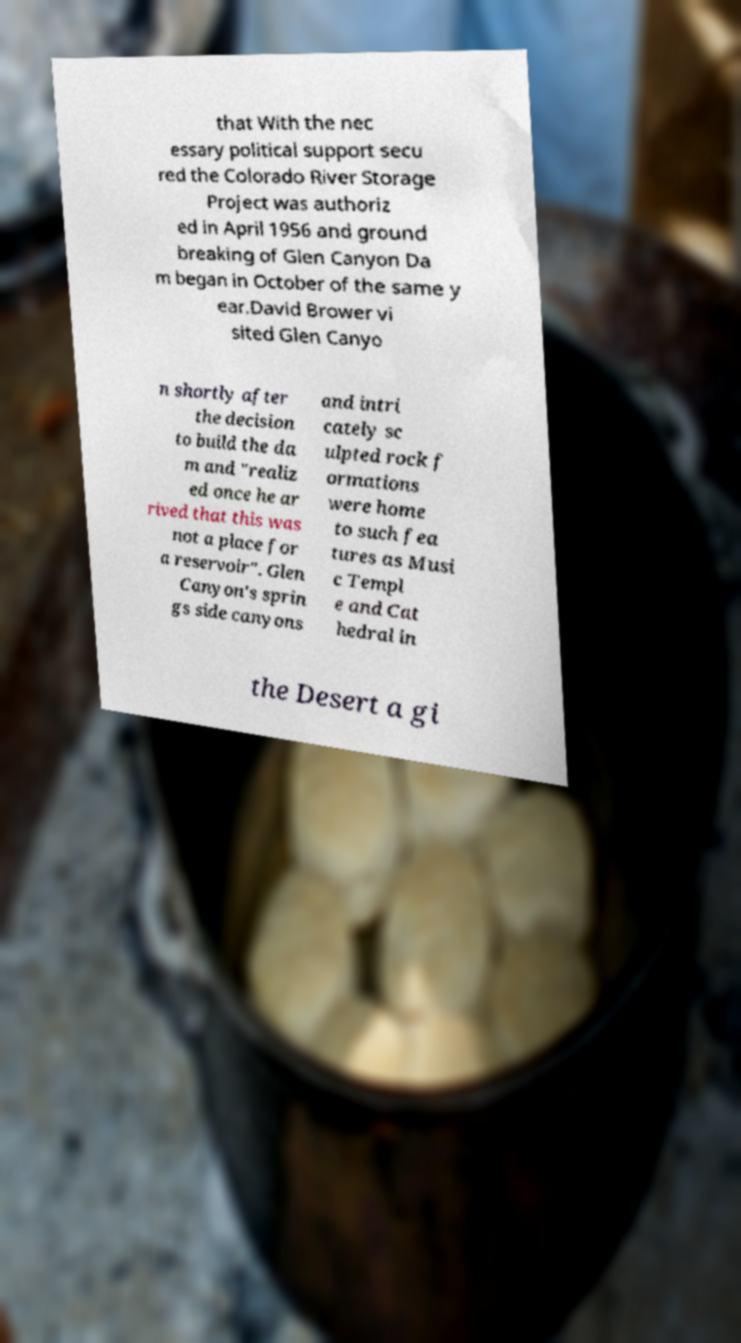Can you accurately transcribe the text from the provided image for me? that With the nec essary political support secu red the Colorado River Storage Project was authoriz ed in April 1956 and ground breaking of Glen Canyon Da m began in October of the same y ear.David Brower vi sited Glen Canyo n shortly after the decision to build the da m and "realiz ed once he ar rived that this was not a place for a reservoir". Glen Canyon's sprin gs side canyons and intri cately sc ulpted rock f ormations were home to such fea tures as Musi c Templ e and Cat hedral in the Desert a gi 